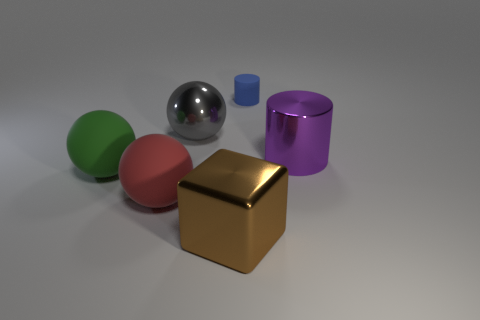Add 1 large purple shiny cylinders. How many objects exist? 7 Subtract all cubes. How many objects are left? 5 Add 2 tiny cylinders. How many tiny cylinders are left? 3 Add 4 big gray things. How many big gray things exist? 5 Subtract 0 purple spheres. How many objects are left? 6 Subtract all red balls. Subtract all small rubber things. How many objects are left? 4 